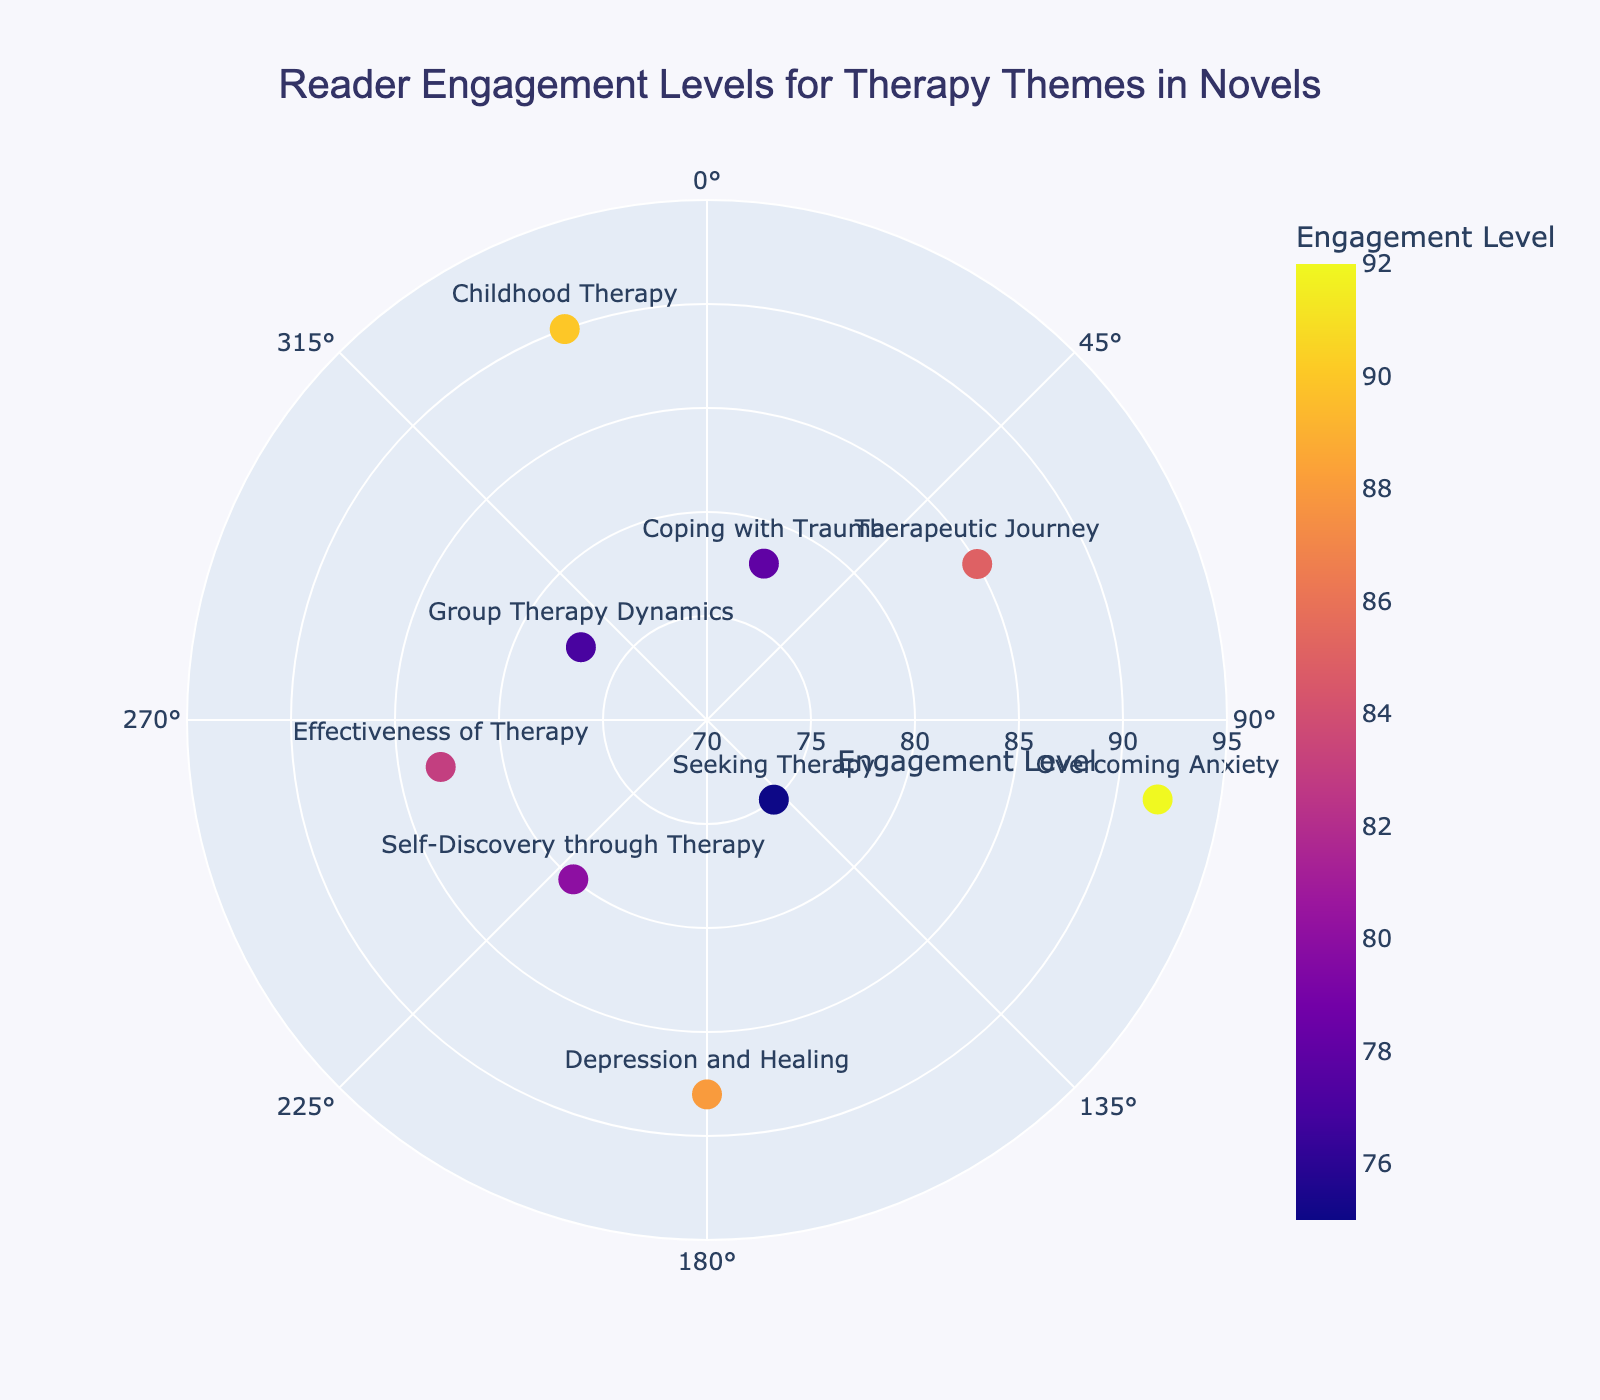What's the title of the chart? The title is given at the top of the chart.
Answer: Reader Engagement Levels for Therapy Themes in Novels How many themes are represented in the chart? Count the number of unique data points with text labels indicating themes.
Answer: 9 Which theme has the highest engagement level? Look for the data point with the highest radial (r) value. "Overcoming Anxiety" has the highest engagement level since it has the maximum radial distance.
Answer: Overcoming Anxiety What is the engagement level for the theme "Coping with Trauma"? Locate the point labelled "Coping with Trauma" and read its radial value.
Answer: 78 Which theme has the lowest engagement level? Identify the data point with the smallest radial (r) value. "Seeking Therapy" has the lowest engagement level.
Answer: Seeking Therapy What is the median engagement level of all themes? List the engagement levels (75, 77, 78, 80, 83, 85, 88, 90, 92) and find the middle value when they are sorted. The sorted engagement levels place 83 in the middle as the 5th value.
Answer: 83 How does the engagement for "Self-Discovery through Therapy" compare to "Effectiveness of Therapy"? Check the radial values for both themes. "Self-Discovery through Therapy" (80) is slightly lower than "Effectiveness of Therapy" (83).
Answer: Self-Discovery through Therapy is lower How many themes have an engagement level above 85? Identify and count all data points with radial values greater than 85. The themes "Overcoming Anxiety" (92), "Childhood Therapy" (90), and "Depression and Healing" (88) all exceed this threshold.
Answer: 3 What is the combined engagement level for "Group Therapy Dynamics" and "Childhood Therapy"? Sum the engagement levels for both themes. "Group Therapy Dynamics" (77) + "Childhood Therapy" (90) = 167
Answer: 167 